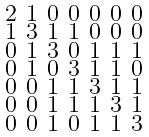<formula> <loc_0><loc_0><loc_500><loc_500>\begin{smallmatrix} 2 & 1 & 0 & 0 & 0 & 0 & 0 \\ 1 & 3 & 1 & 1 & 0 & 0 & 0 \\ 0 & 1 & 3 & 0 & 1 & 1 & 1 \\ 0 & 1 & 0 & 3 & 1 & 1 & 0 \\ 0 & 0 & 1 & 1 & 3 & 1 & 1 \\ 0 & 0 & 1 & 1 & 1 & 3 & 1 \\ 0 & 0 & 1 & 0 & 1 & 1 & 3 \end{smallmatrix}</formula> 